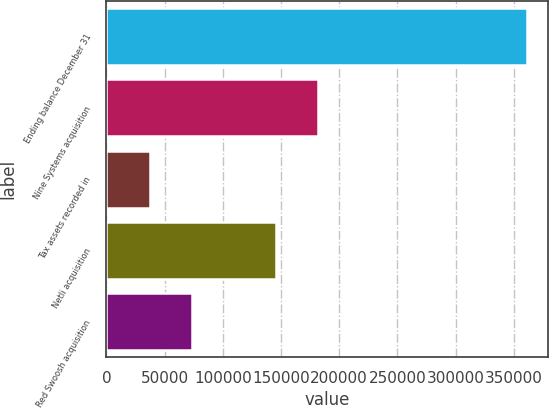<chart> <loc_0><loc_0><loc_500><loc_500><bar_chart><fcel>Ending balance December 31<fcel>Nine Systems acquisition<fcel>Tax assets recorded in<fcel>Netli acquisition<fcel>Red Swoosh acquisition<nl><fcel>361637<fcel>181548<fcel>37475.9<fcel>145530<fcel>73493.8<nl></chart> 